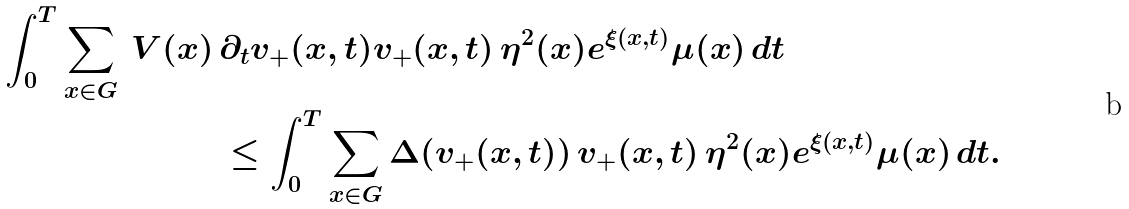Convert formula to latex. <formula><loc_0><loc_0><loc_500><loc_500>\int _ { 0 } ^ { T } \sum _ { x \in G } \, V ( x ) \, & \partial _ { t } v _ { + } ( x , t ) v _ { + } ( x , t ) \, \eta ^ { 2 } ( x ) e ^ { \xi ( x , t ) } \mu ( x ) \, d t \\ & \leq \int _ { 0 } ^ { T } \sum _ { x \in G } \Delta ( v _ { + } ( x , t ) ) \, v _ { + } ( x , t ) \, \eta ^ { 2 } ( x ) e ^ { \xi ( x , t ) } \mu ( x ) \, d t .</formula> 